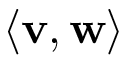Convert formula to latex. <formula><loc_0><loc_0><loc_500><loc_500>\langle v , w \rangle</formula> 